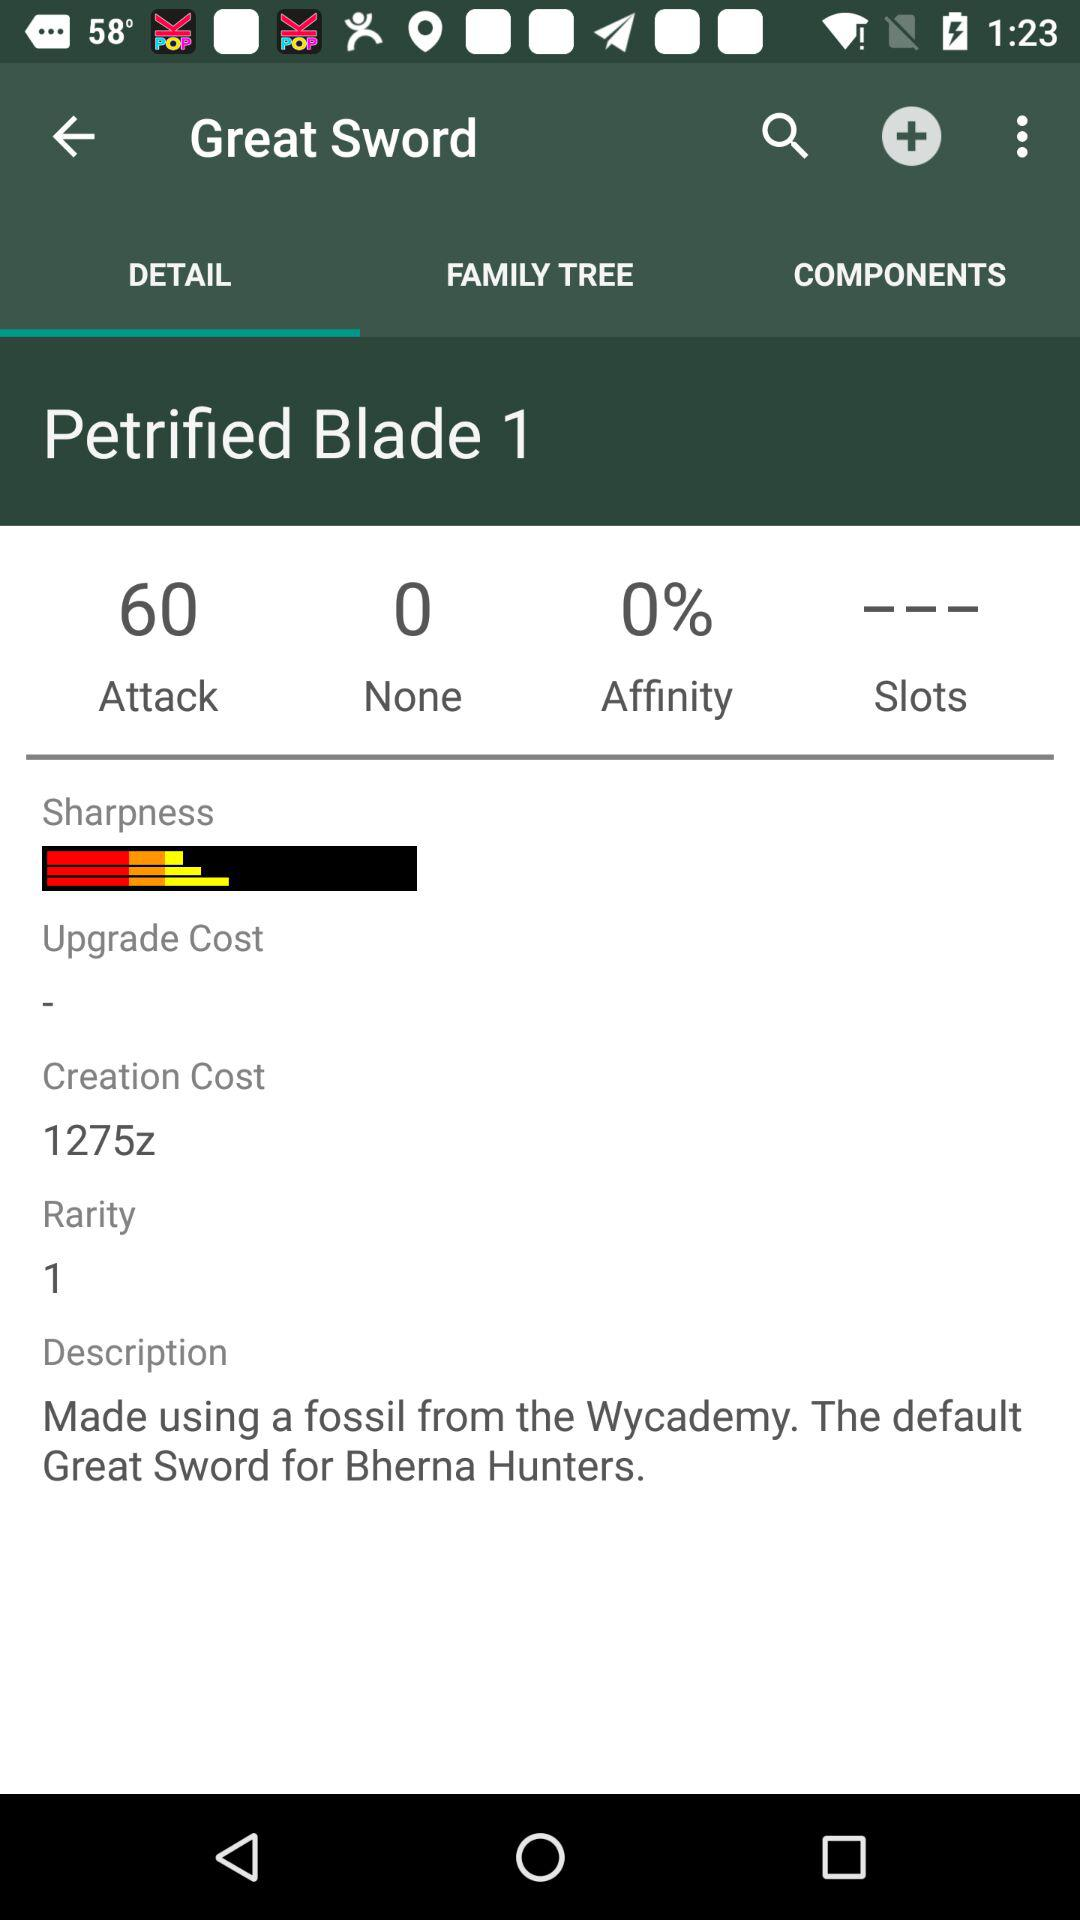What is the percentage of affinity? The percentage of affinity is 0. 